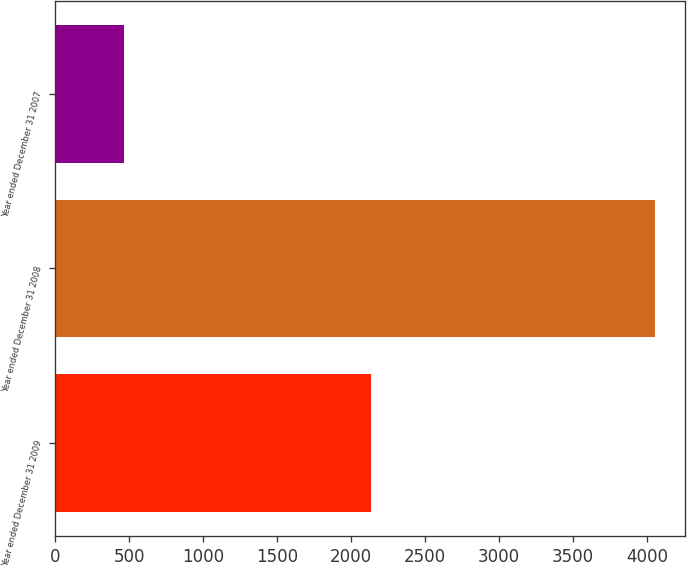Convert chart. <chart><loc_0><loc_0><loc_500><loc_500><bar_chart><fcel>Year ended December 31 2009<fcel>Year ended December 31 2008<fcel>Year ended December 31 2007<nl><fcel>2135<fcel>4054<fcel>461<nl></chart> 